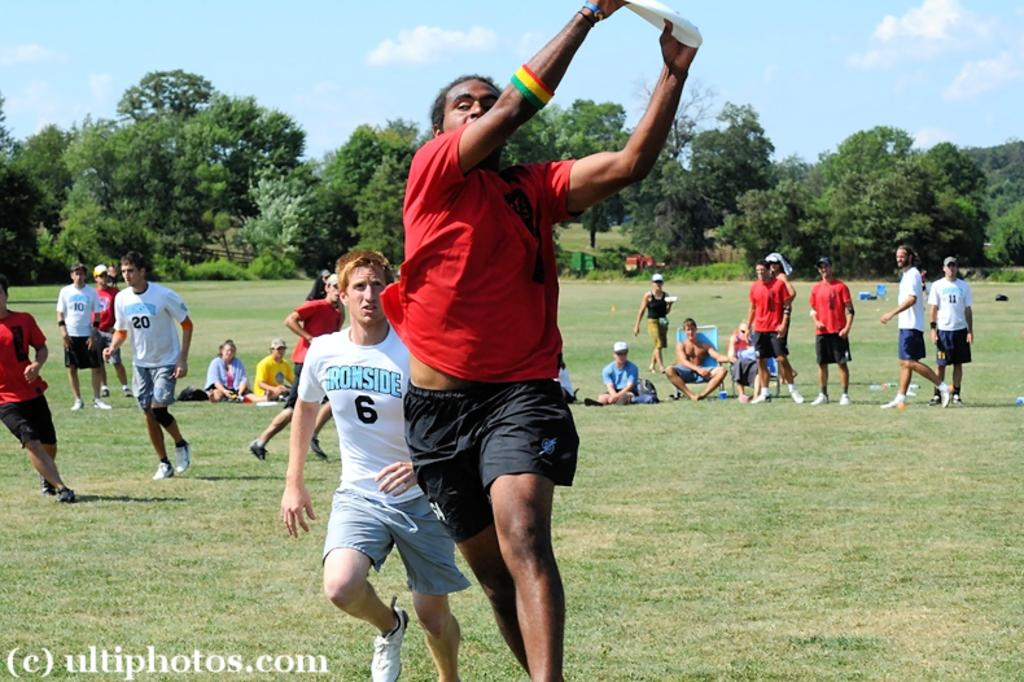<image>
Render a clear and concise summary of the photo. Player number 6, wearing an Ironside shirt, tries to catch up to the man with the frisbee. 